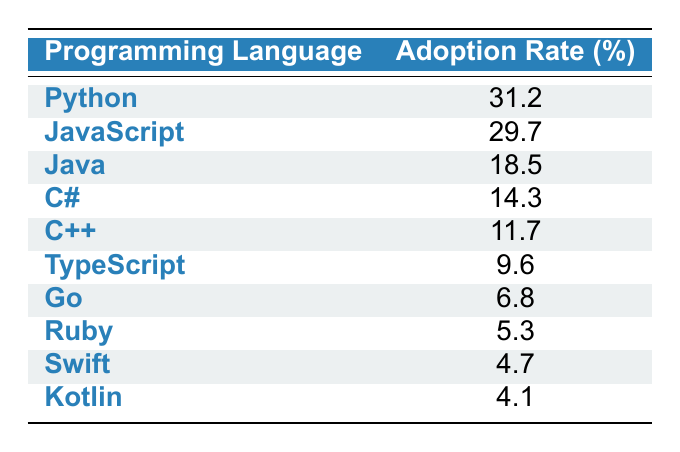What is the adoption rate of Python? The table lists the adoption rate of Python as 31.2%.
Answer: 31.2% Which programming language has the second highest adoption rate? By looking at the adoption rates, JavaScript has an adoption rate of 29.7%, which is the second highest after Python.
Answer: JavaScript What is the sum of the adoption rates of Java and C++? The adoption rate of Java is 18.5% and the adoption rate of C++ is 11.7%. Summing these together gives 18.5 + 11.7 = 30.2%.
Answer: 30.2% Is the adoption rate of Ruby higher than that of Swift? Ruby has an adoption rate of 5.3% and Swift has an adoption rate of 4.7%. Since 5.3% is greater than 4.7%, the statement is true.
Answer: Yes What is the average adoption rate of the top three programming languages? The top three languages are Python, JavaScript, and Java with adoption rates of 31.2%, 29.7%, and 18.5% respectively. The sum is 31.2 + 29.7 + 18.5 = 79.4%. Dividing by 3 gives an average of 79.4 / 3 = 26.47%.
Answer: 26.47% Which programming language has the smallest adoption rate? The table shows that Kotlin has the smallest adoption rate at 4.1%.
Answer: Kotlin Is there a programming language with an adoption rate of 10% or more? Both Python (31.2%) and JavaScript (29.7%) have adoption rates over 10%. There are indeed languages with such rates, confirming the statement is true.
Answer: Yes What is the difference in adoption rates between C# and Go? C# has an adoption rate of 14.3% and Go has an adoption rate of 6.8%. To find the difference, subtract: 14.3 - 6.8 = 7.5%.
Answer: 7.5% Which languages are primarily used for Web Development? Python, JavaScript, and Ruby are listed as popular languages for Web Development usage.
Answer: Python, JavaScript, Ruby 